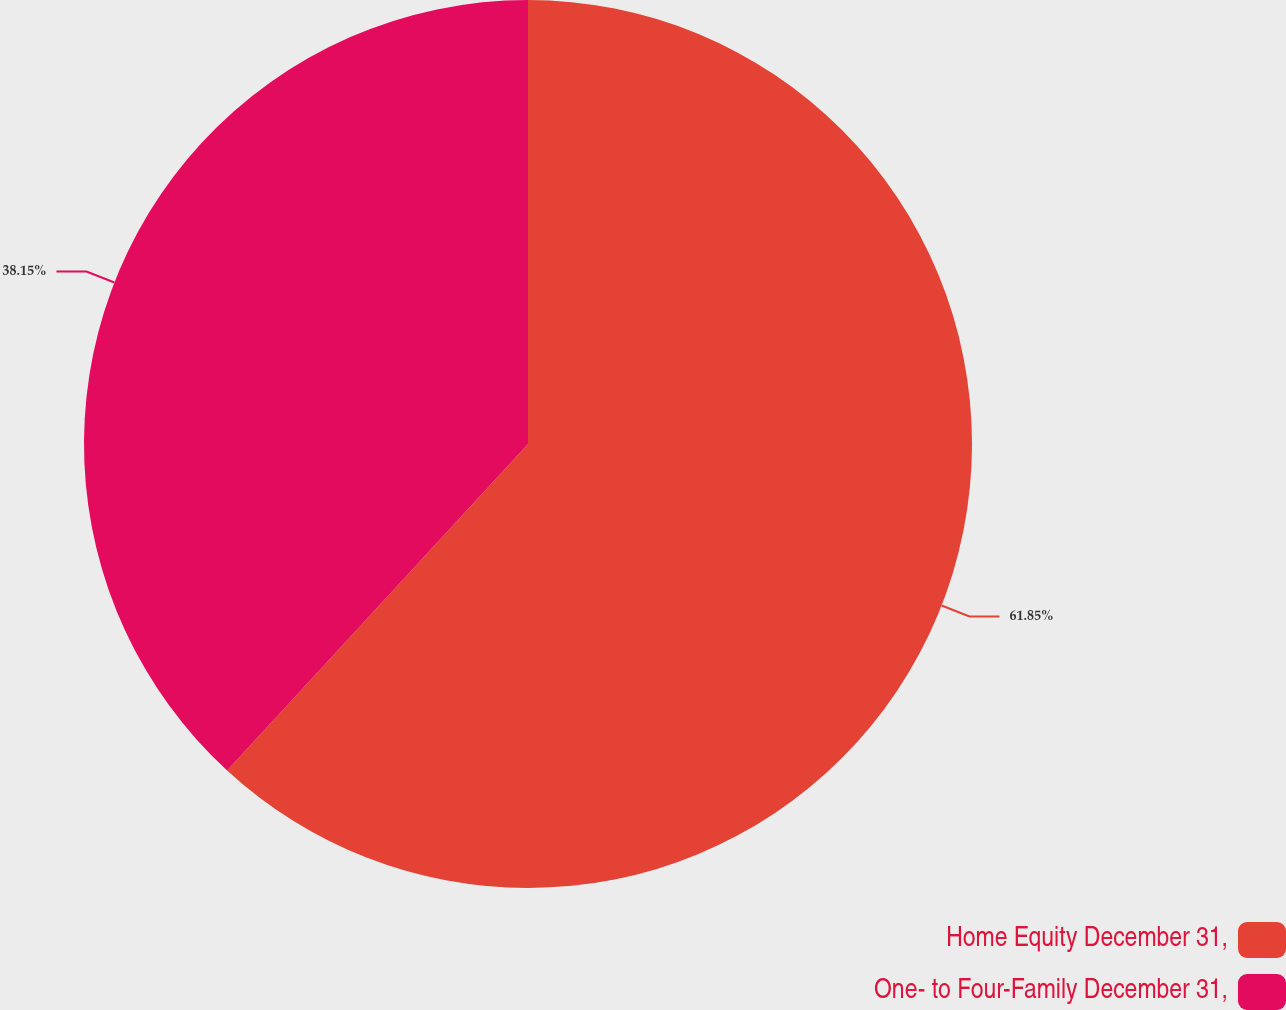<chart> <loc_0><loc_0><loc_500><loc_500><pie_chart><fcel>Home Equity December 31,<fcel>One- to Four-Family December 31,<nl><fcel>61.85%<fcel>38.15%<nl></chart> 